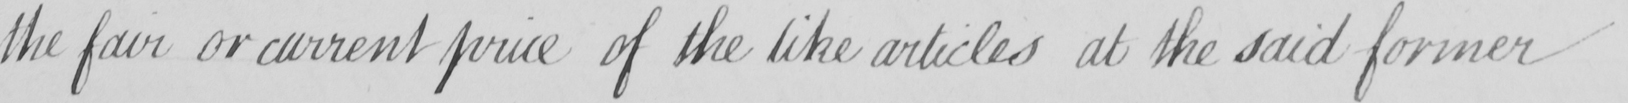Transcribe the text shown in this historical manuscript line. the fair or current price of the like articles at the said former 